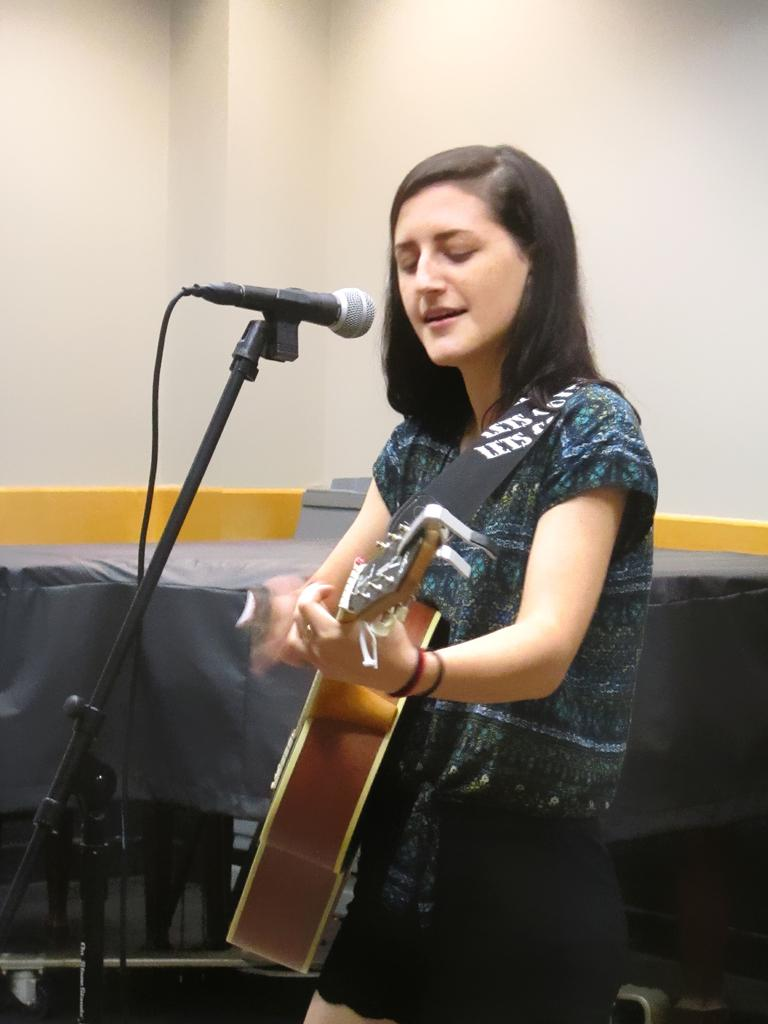Who is the main subject in the image? There is a girl in the image. What is the girl wearing? The girl is wearing a blue color printed top and a black skirt. What is the girl holding in her hand? The girl is holding a guitar in her hand. What is the girl doing in the image? The girl is singing into a microphone. What can be seen in the background of the image? There is a white color wall in the background of the image. What type of sea can be seen in the background of the image? There is no sea present in the image; it features a white color wall in the background. Is the girl part of a group in the image? The image only shows the girl, so there is no indication of a group. 